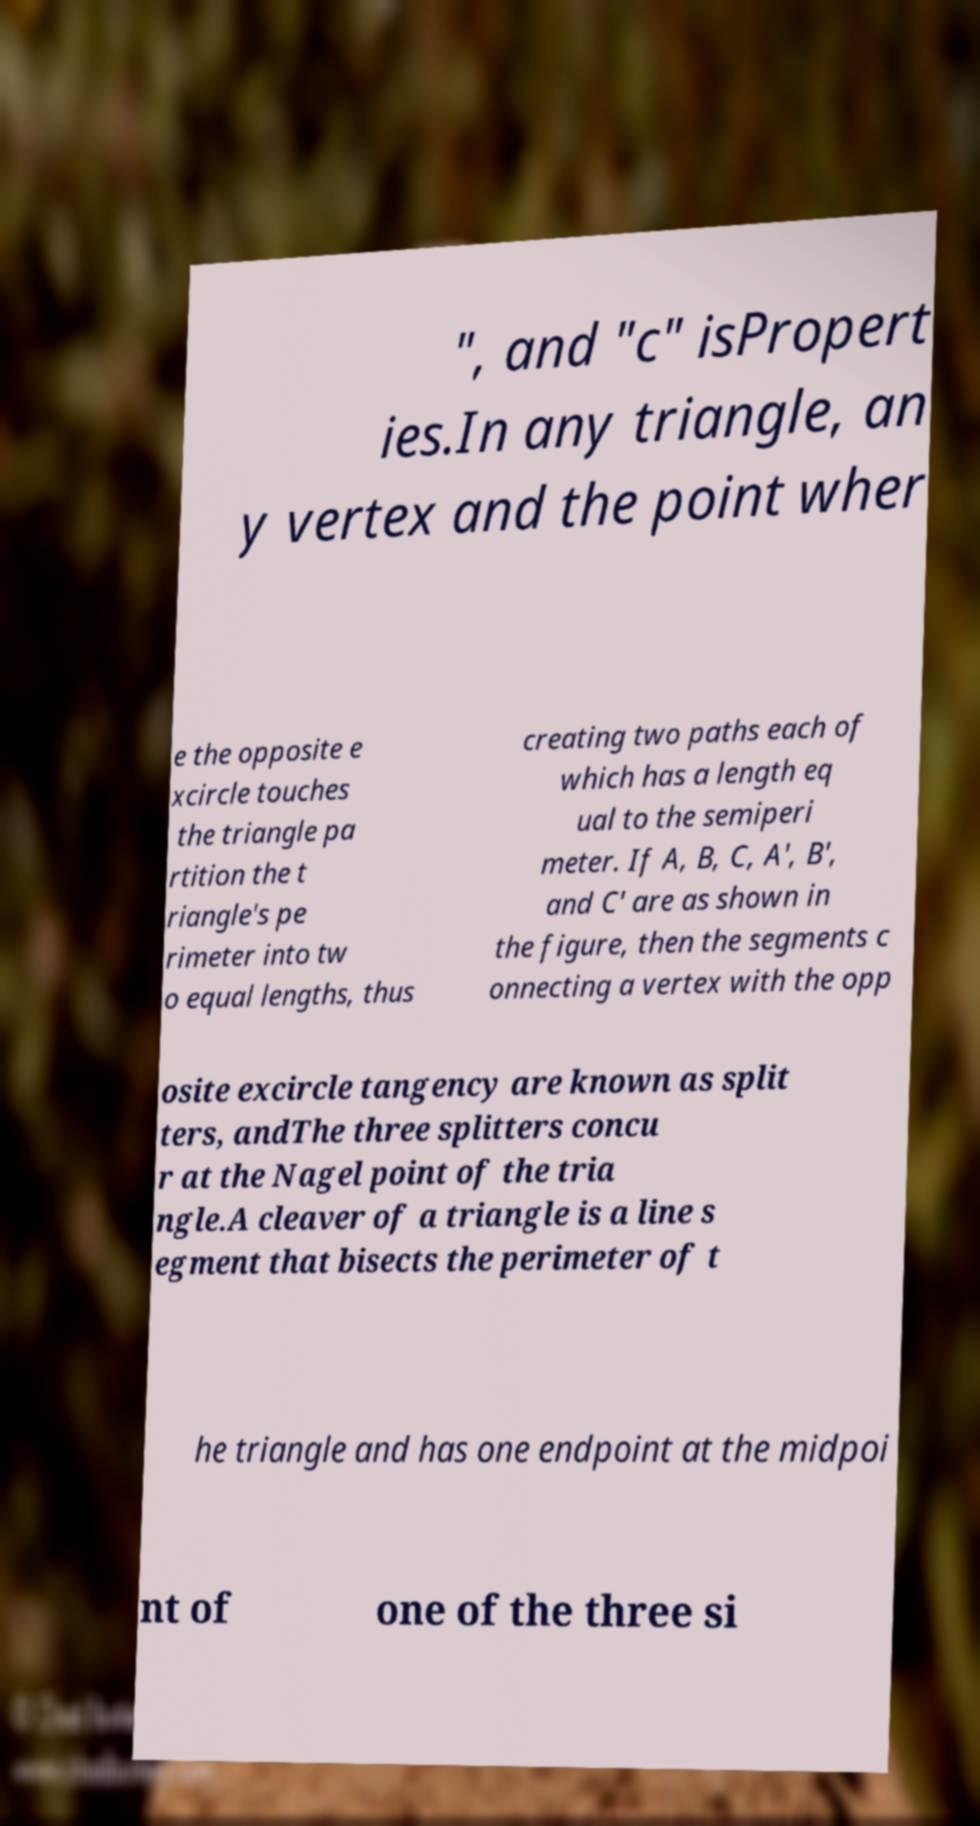For documentation purposes, I need the text within this image transcribed. Could you provide that? ", and "c" isPropert ies.In any triangle, an y vertex and the point wher e the opposite e xcircle touches the triangle pa rtition the t riangle's pe rimeter into tw o equal lengths, thus creating two paths each of which has a length eq ual to the semiperi meter. If A, B, C, A', B', and C' are as shown in the figure, then the segments c onnecting a vertex with the opp osite excircle tangency are known as split ters, andThe three splitters concu r at the Nagel point of the tria ngle.A cleaver of a triangle is a line s egment that bisects the perimeter of t he triangle and has one endpoint at the midpoi nt of one of the three si 